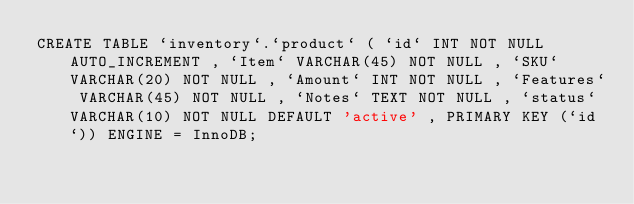Convert code to text. <code><loc_0><loc_0><loc_500><loc_500><_SQL_>CREATE TABLE `inventory`.`product` ( `id` INT NOT NULL AUTO_INCREMENT , `Item` VARCHAR(45) NOT NULL , `SKU` VARCHAR(20) NOT NULL , `Amount` INT NOT NULL , `Features` VARCHAR(45) NOT NULL , `Notes` TEXT NOT NULL , `status` VARCHAR(10) NOT NULL DEFAULT 'active' , PRIMARY KEY (`id`)) ENGINE = InnoDB;
</code> 